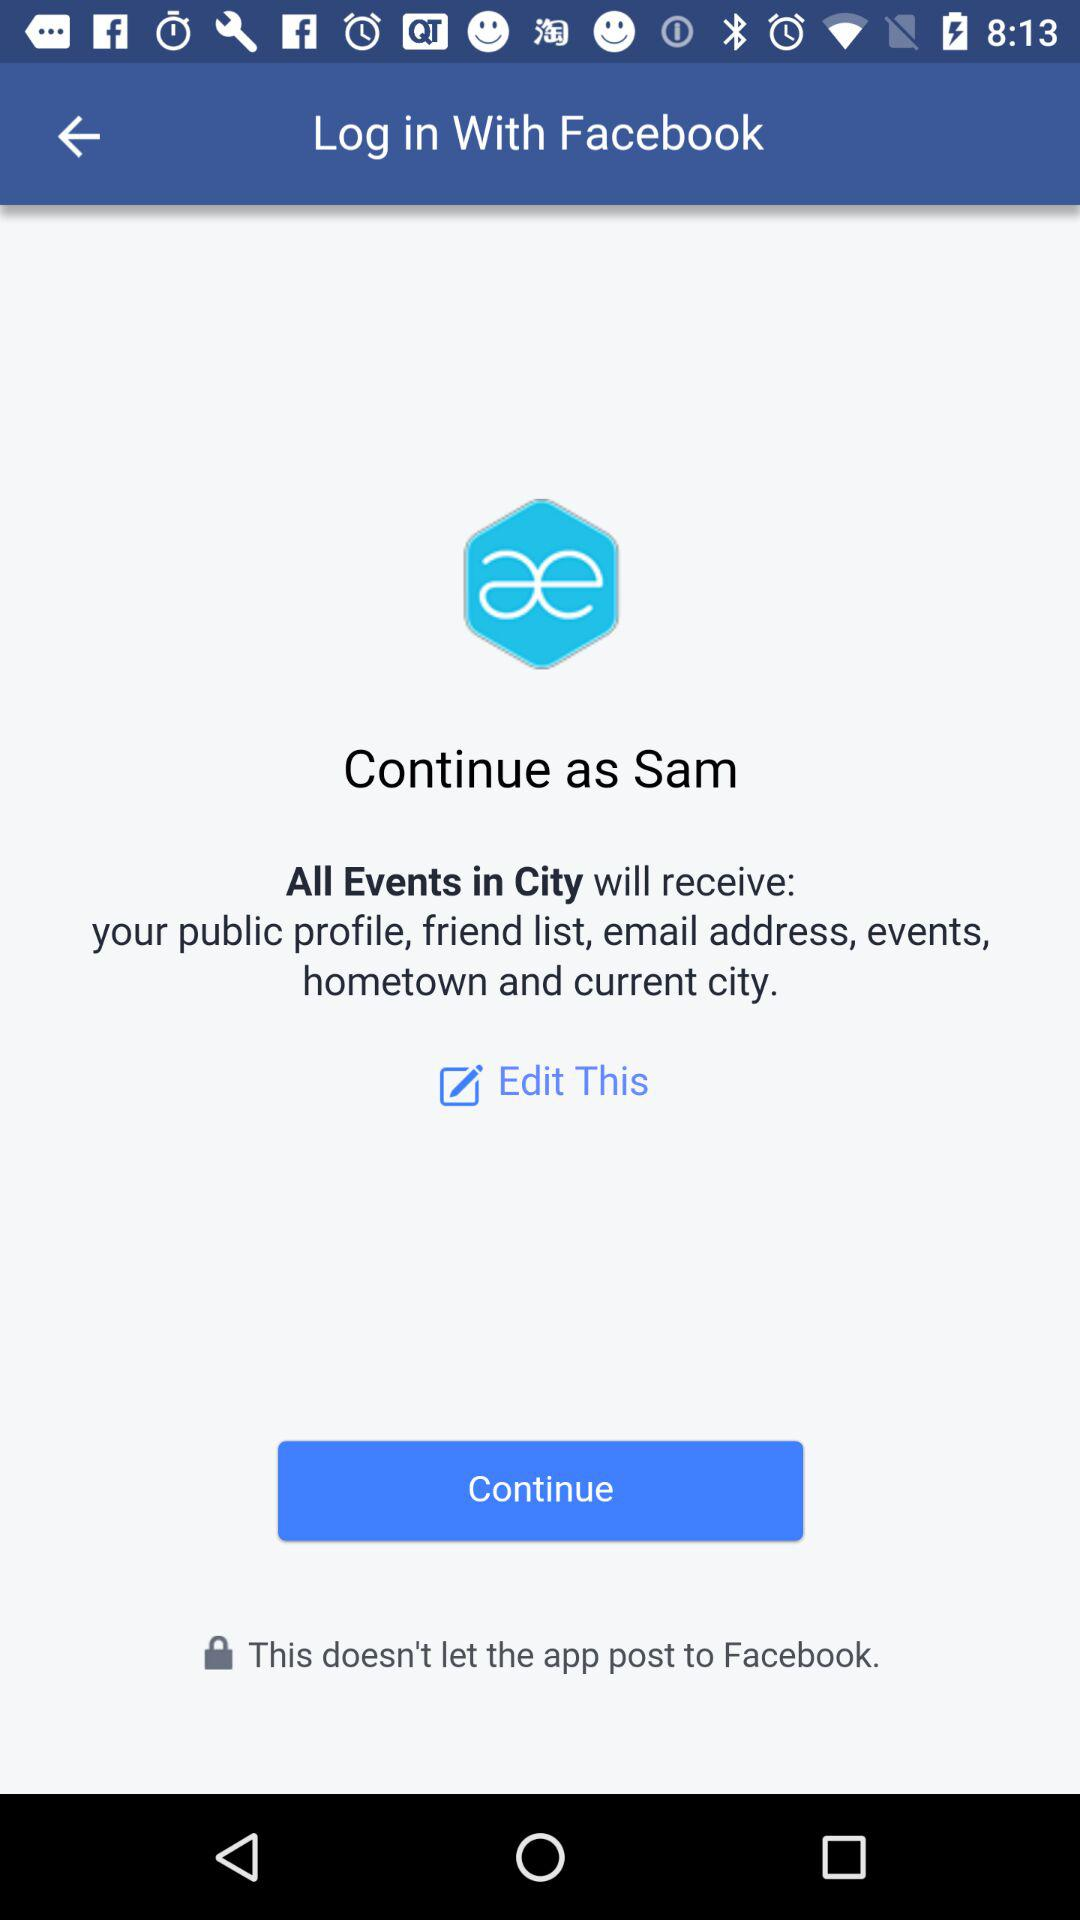What application is asking for permission? The application asking for permission is "All Events in City". 